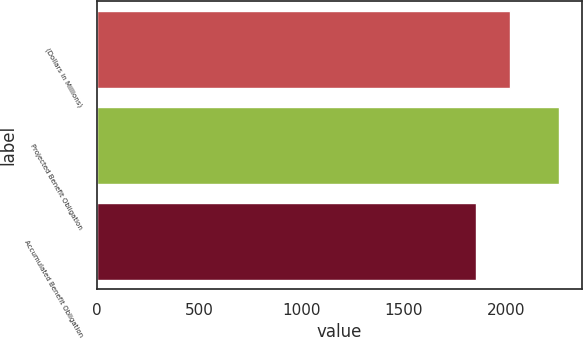<chart> <loc_0><loc_0><loc_500><loc_500><bar_chart><fcel>(Dollars in Millions)<fcel>Projected Benefit Obligation<fcel>Accumulated Benefit Obligation<nl><fcel>2017<fcel>2257<fcel>1849<nl></chart> 